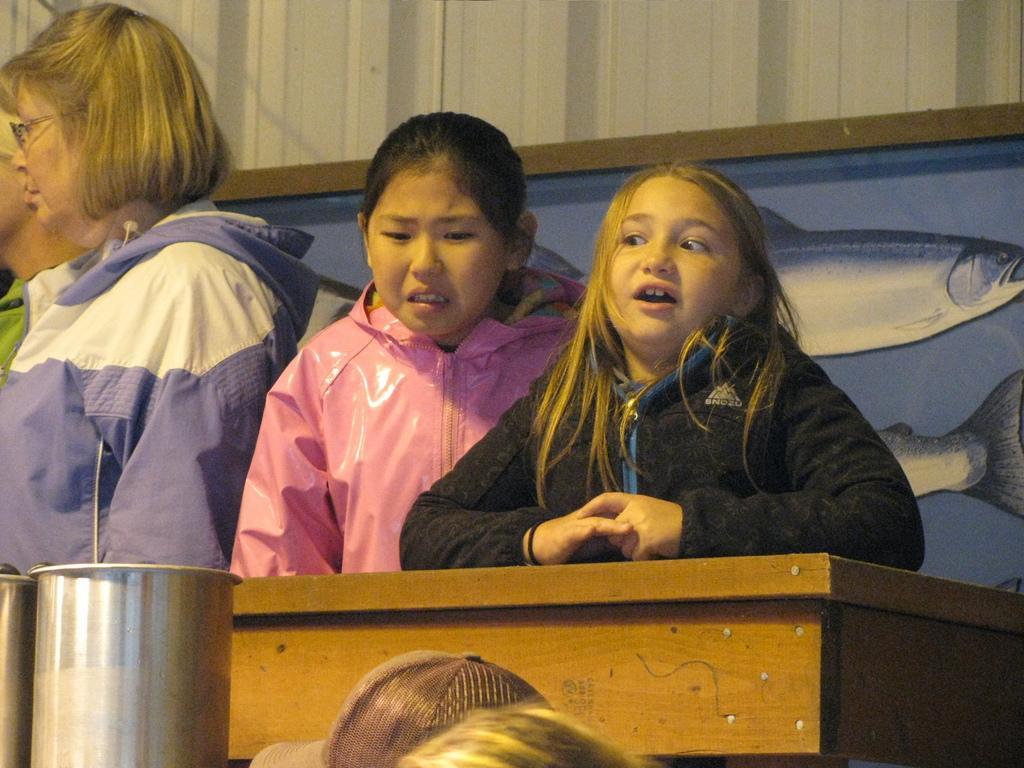Please provide a concise description of this image. This picture describes about group of people, in the middle of the image we can see a table, and we can find painting on the wall. At the left bottom of the image we can see steel containers. 